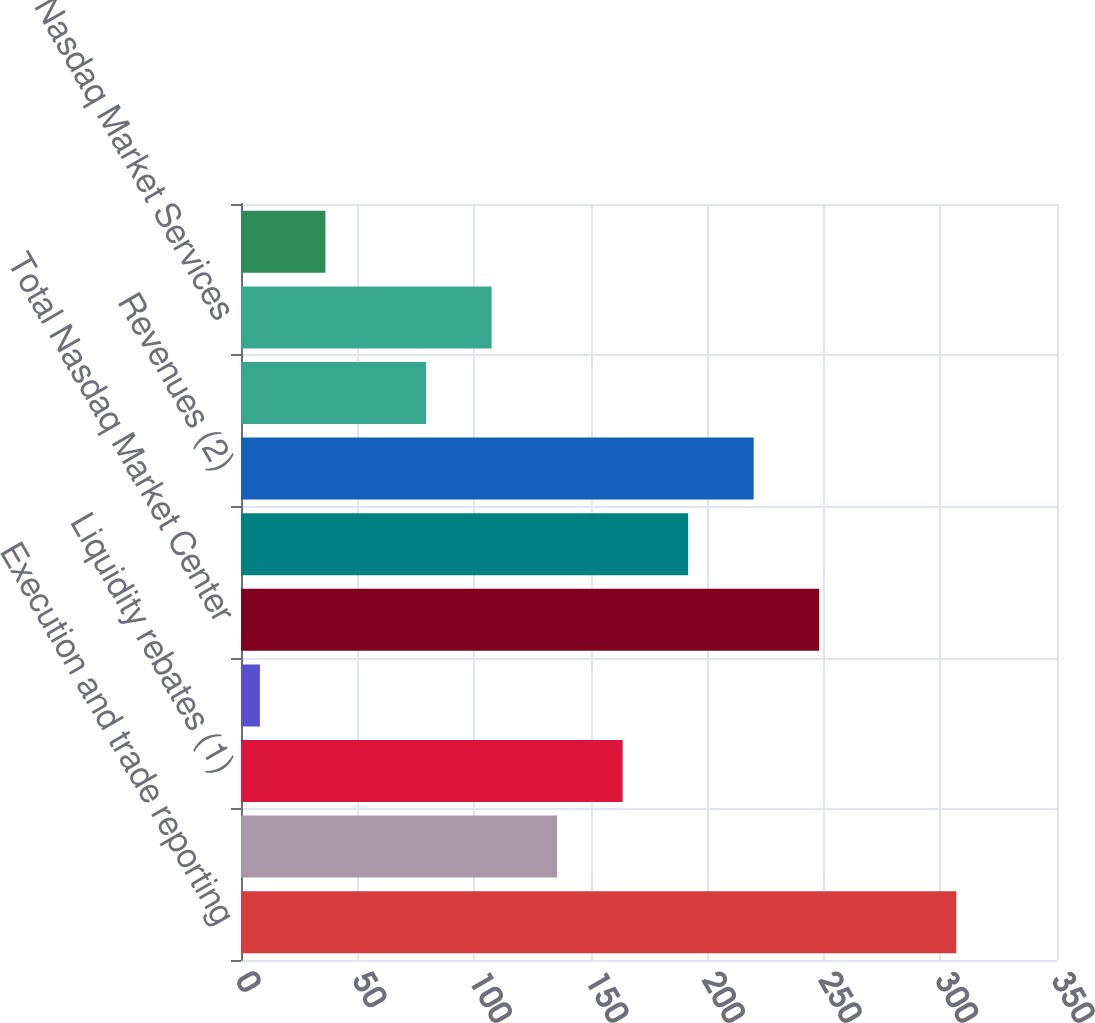Convert chart. <chart><loc_0><loc_0><loc_500><loc_500><bar_chart><fcel>Execution and trade reporting<fcel>Access services revenues<fcel>Liquidity rebates (1)<fcel>Tape fee revenue sharing<fcel>Total Nasdaq Market Center<fcel>Gross margin from Nasdaq<fcel>Revenues (2)<fcel>UTP Plan revenue sharing<fcel>Total Nasdaq Market Services<fcel>Other Market Services revenues<nl><fcel>306.8<fcel>135.6<fcel>163.7<fcel>8.1<fcel>248<fcel>191.8<fcel>219.9<fcel>79.4<fcel>107.5<fcel>36.2<nl></chart> 